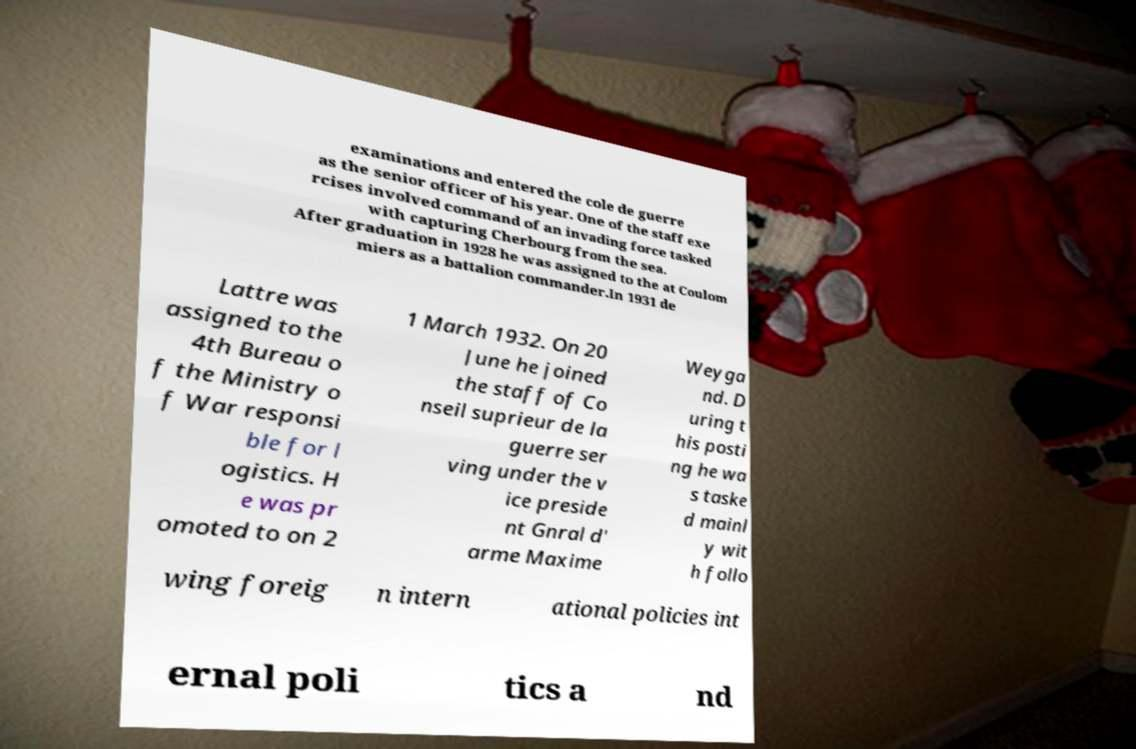What messages or text are displayed in this image? I need them in a readable, typed format. examinations and entered the cole de guerre as the senior officer of his year. One of the staff exe rcises involved command of an invading force tasked with capturing Cherbourg from the sea. After graduation in 1928 he was assigned to the at Coulom miers as a battalion commander.In 1931 de Lattre was assigned to the 4th Bureau o f the Ministry o f War responsi ble for l ogistics. H e was pr omoted to on 2 1 March 1932. On 20 June he joined the staff of Co nseil suprieur de la guerre ser ving under the v ice preside nt Gnral d' arme Maxime Weyga nd. D uring t his posti ng he wa s taske d mainl y wit h follo wing foreig n intern ational policies int ernal poli tics a nd 